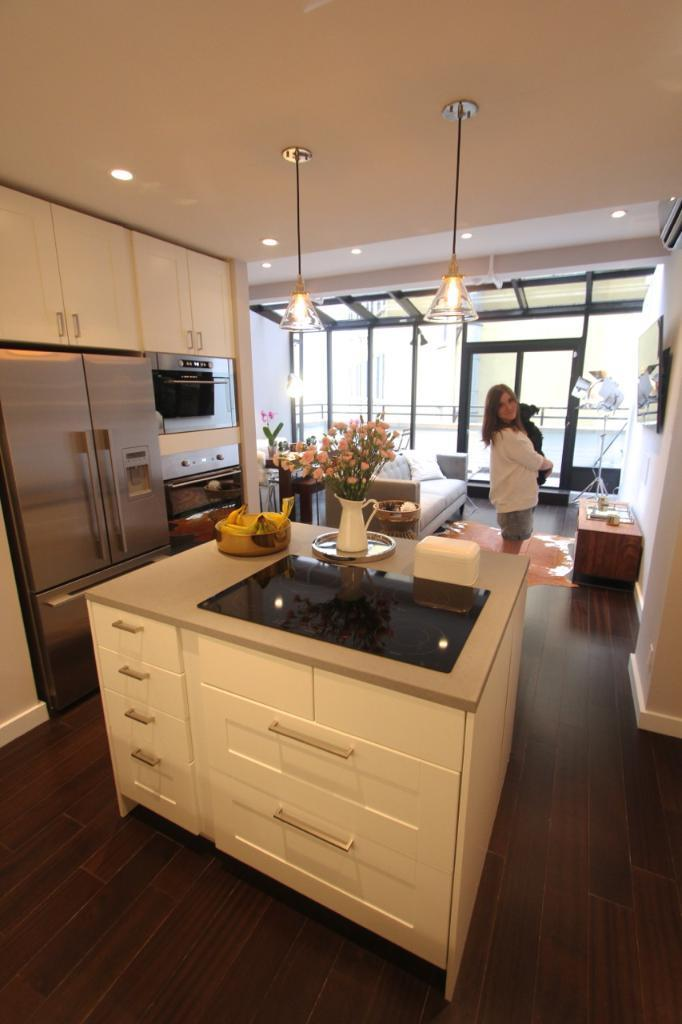Who is the main subject in the image? There is a girl in the image. Where is the girl located? The girl is standing in a room. What is the girl doing in the image? The girl is posing for a camera. What type of zinc is the girl holding in the image? There is no zinc present in the image. Is the girl driving a vehicle in the image? No, the girl is not driving a vehicle in the image; she is standing in a room and posing for a camera. 